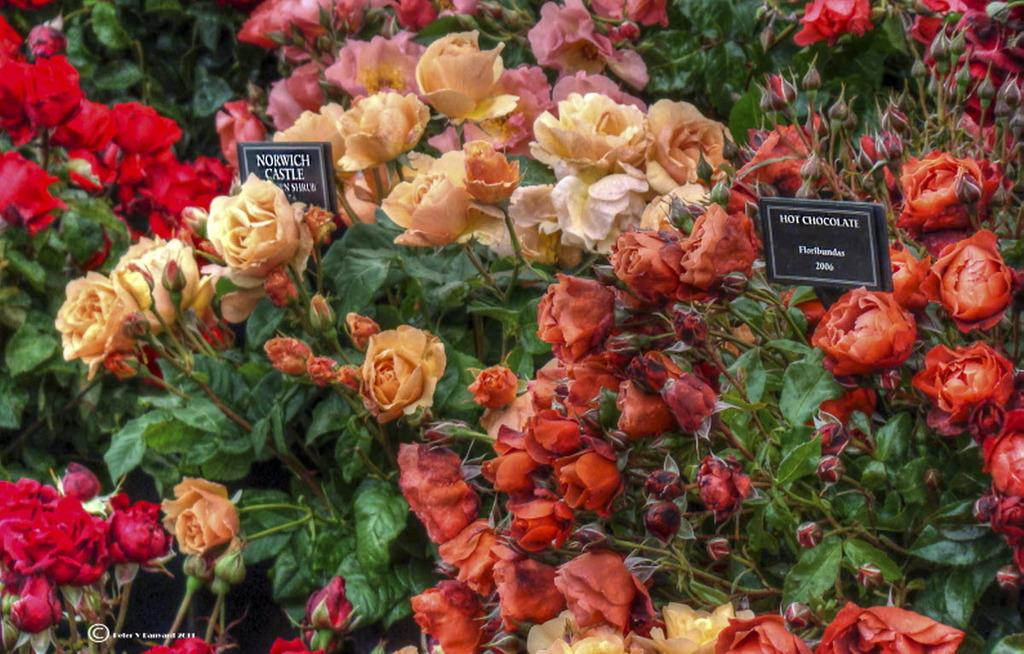What type of flowers are in the image? There are roses in the image. Can you describe the appearance of the roses? The roses have different colors. What type of division is taking place in the image? There is no division taking place in the image; it features roses with different colors. 